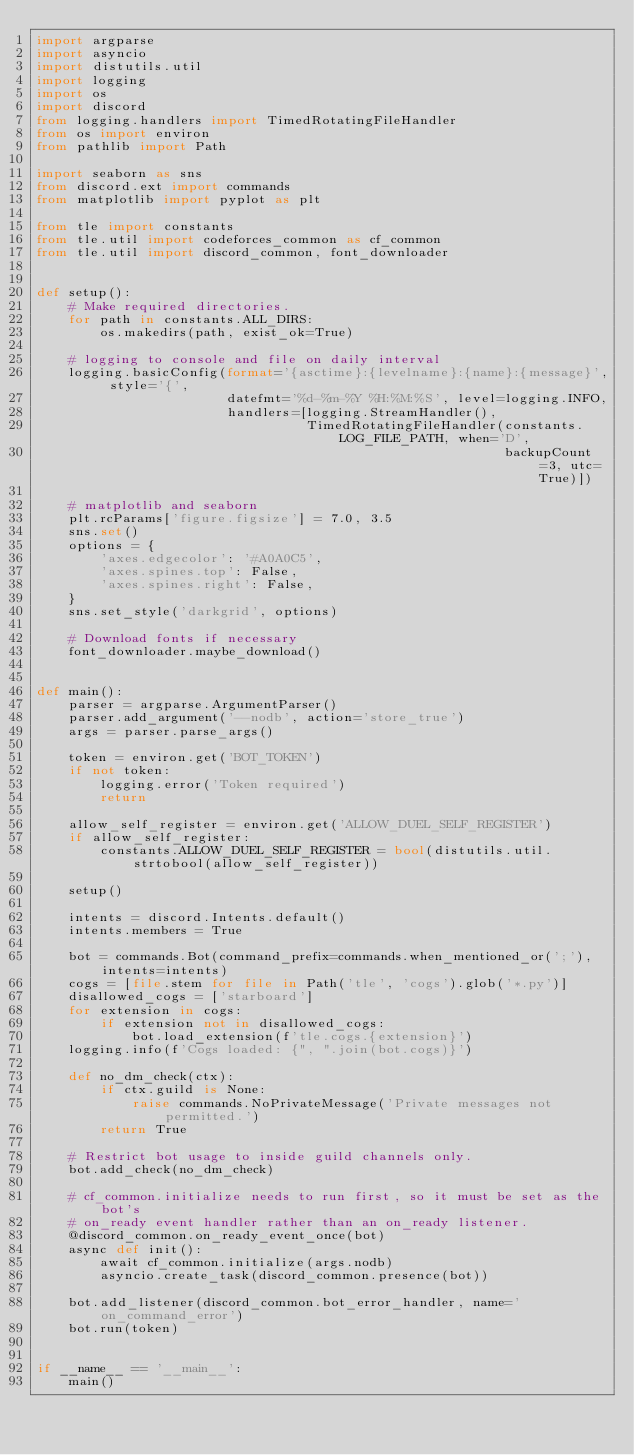Convert code to text. <code><loc_0><loc_0><loc_500><loc_500><_Python_>import argparse
import asyncio
import distutils.util
import logging
import os
import discord
from logging.handlers import TimedRotatingFileHandler
from os import environ
from pathlib import Path

import seaborn as sns
from discord.ext import commands
from matplotlib import pyplot as plt

from tle import constants
from tle.util import codeforces_common as cf_common
from tle.util import discord_common, font_downloader


def setup():
    # Make required directories.
    for path in constants.ALL_DIRS:
        os.makedirs(path, exist_ok=True)

    # logging to console and file on daily interval
    logging.basicConfig(format='{asctime}:{levelname}:{name}:{message}', style='{',
                        datefmt='%d-%m-%Y %H:%M:%S', level=logging.INFO,
                        handlers=[logging.StreamHandler(),
                                  TimedRotatingFileHandler(constants.LOG_FILE_PATH, when='D',
                                                           backupCount=3, utc=True)])

    # matplotlib and seaborn
    plt.rcParams['figure.figsize'] = 7.0, 3.5
    sns.set()
    options = {
        'axes.edgecolor': '#A0A0C5',
        'axes.spines.top': False,
        'axes.spines.right': False,
    }
    sns.set_style('darkgrid', options)

    # Download fonts if necessary
    font_downloader.maybe_download()


def main():
    parser = argparse.ArgumentParser()
    parser.add_argument('--nodb', action='store_true')
    args = parser.parse_args()

    token = environ.get('BOT_TOKEN')
    if not token:
        logging.error('Token required')
        return

    allow_self_register = environ.get('ALLOW_DUEL_SELF_REGISTER')
    if allow_self_register:
        constants.ALLOW_DUEL_SELF_REGISTER = bool(distutils.util.strtobool(allow_self_register))

    setup()
    
    intents = discord.Intents.default()
    intents.members = True

    bot = commands.Bot(command_prefix=commands.when_mentioned_or(';'), intents=intents)
    cogs = [file.stem for file in Path('tle', 'cogs').glob('*.py')]
    disallowed_cogs = ['starboard']
    for extension in cogs:
        if extension not in disallowed_cogs:
            bot.load_extension(f'tle.cogs.{extension}')
    logging.info(f'Cogs loaded: {", ".join(bot.cogs)}')

    def no_dm_check(ctx):
        if ctx.guild is None:
            raise commands.NoPrivateMessage('Private messages not permitted.')
        return True

    # Restrict bot usage to inside guild channels only.
    bot.add_check(no_dm_check)

    # cf_common.initialize needs to run first, so it must be set as the bot's
    # on_ready event handler rather than an on_ready listener.
    @discord_common.on_ready_event_once(bot)
    async def init():
        await cf_common.initialize(args.nodb)
        asyncio.create_task(discord_common.presence(bot))

    bot.add_listener(discord_common.bot_error_handler, name='on_command_error')
    bot.run(token)


if __name__ == '__main__':
    main()
</code> 